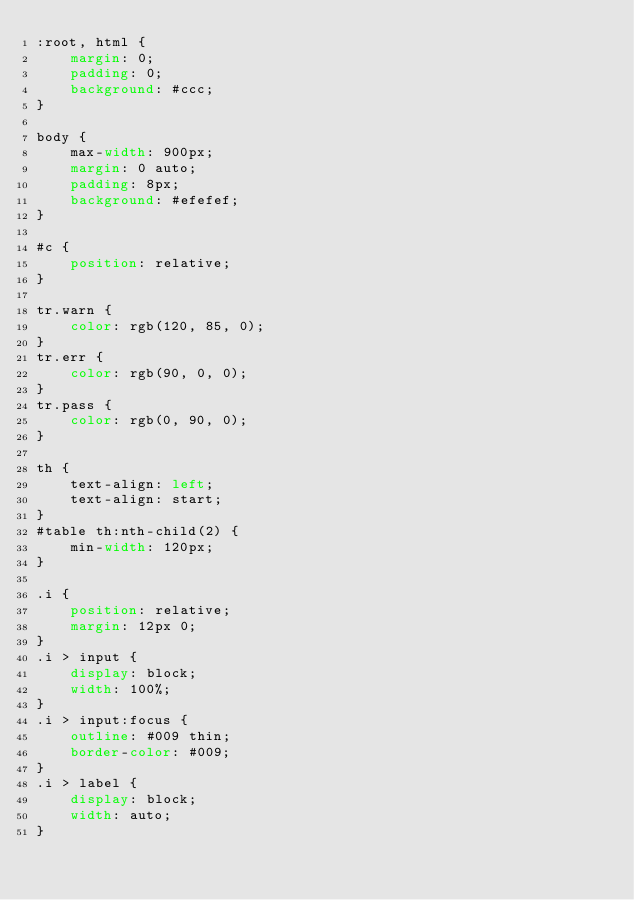<code> <loc_0><loc_0><loc_500><loc_500><_CSS_>:root, html {
    margin: 0;
    padding: 0;
    background: #ccc;
}

body {
    max-width: 900px;
    margin: 0 auto;
    padding: 8px;
    background: #efefef;
}

#c {
    position: relative;
}

tr.warn {
    color: rgb(120, 85, 0);
}
tr.err {
    color: rgb(90, 0, 0);
}
tr.pass {
    color: rgb(0, 90, 0);
}

th {
    text-align: left;
    text-align: start;
}
#table th:nth-child(2) {
    min-width: 120px;
}

.i {
    position: relative;
    margin: 12px 0;
}
.i > input {
    display: block;
    width: 100%;
}
.i > input:focus {
    outline: #009 thin;
    border-color: #009;
}
.i > label {
    display: block;
    width: auto;
}
</code> 